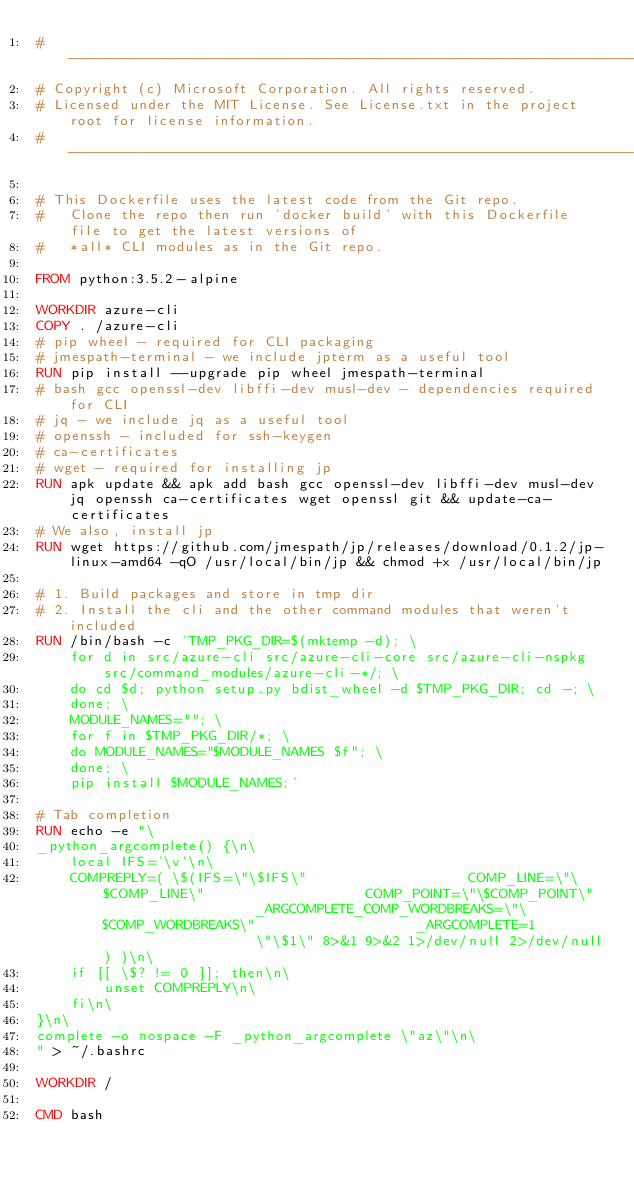Convert code to text. <code><loc_0><loc_0><loc_500><loc_500><_Dockerfile_>#---------------------------------------------------------------------------------------------
# Copyright (c) Microsoft Corporation. All rights reserved.
# Licensed under the MIT License. See License.txt in the project root for license information.
#---------------------------------------------------------------------------------------------

# This Dockerfile uses the latest code from the Git repo.
#   Clone the repo then run 'docker build' with this Dockerfile file to get the latest versions of
#   *all* CLI modules as in the Git repo.

FROM python:3.5.2-alpine

WORKDIR azure-cli
COPY . /azure-cli
# pip wheel - required for CLI packaging
# jmespath-terminal - we include jpterm as a useful tool
RUN pip install --upgrade pip wheel jmespath-terminal
# bash gcc openssl-dev libffi-dev musl-dev - dependencies required for CLI
# jq - we include jq as a useful tool
# openssh - included for ssh-keygen
# ca-certificates 
# wget - required for installing jp
RUN apk update && apk add bash gcc openssl-dev libffi-dev musl-dev jq openssh ca-certificates wget openssl git && update-ca-certificates
# We also, install jp
RUN wget https://github.com/jmespath/jp/releases/download/0.1.2/jp-linux-amd64 -qO /usr/local/bin/jp && chmod +x /usr/local/bin/jp

# 1. Build packages and store in tmp dir
# 2. Install the cli and the other command modules that weren't included
RUN /bin/bash -c 'TMP_PKG_DIR=$(mktemp -d); \
    for d in src/azure-cli src/azure-cli-core src/azure-cli-nspkg src/command_modules/azure-cli-*/; \
    do cd $d; python setup.py bdist_wheel -d $TMP_PKG_DIR; cd -; \
    done; \
    MODULE_NAMES=""; \
    for f in $TMP_PKG_DIR/*; \
    do MODULE_NAMES="$MODULE_NAMES $f"; \
    done; \
    pip install $MODULE_NAMES;'

# Tab completion
RUN echo -e "\
_python_argcomplete() {\n\
    local IFS='\v'\n\
    COMPREPLY=( \$(IFS=\"\$IFS\"                   COMP_LINE=\"\$COMP_LINE\"                   COMP_POINT=\"\$COMP_POINT\"                   _ARGCOMPLETE_COMP_WORDBREAKS=\"\$COMP_WORDBREAKS\"                   _ARGCOMPLETE=1                   \"\$1\" 8>&1 9>&2 1>/dev/null 2>/dev/null) )\n\
    if [[ \$? != 0 ]]; then\n\
        unset COMPREPLY\n\
    fi\n\
}\n\
complete -o nospace -F _python_argcomplete \"az\"\n\
" > ~/.bashrc

WORKDIR /

CMD bash
</code> 